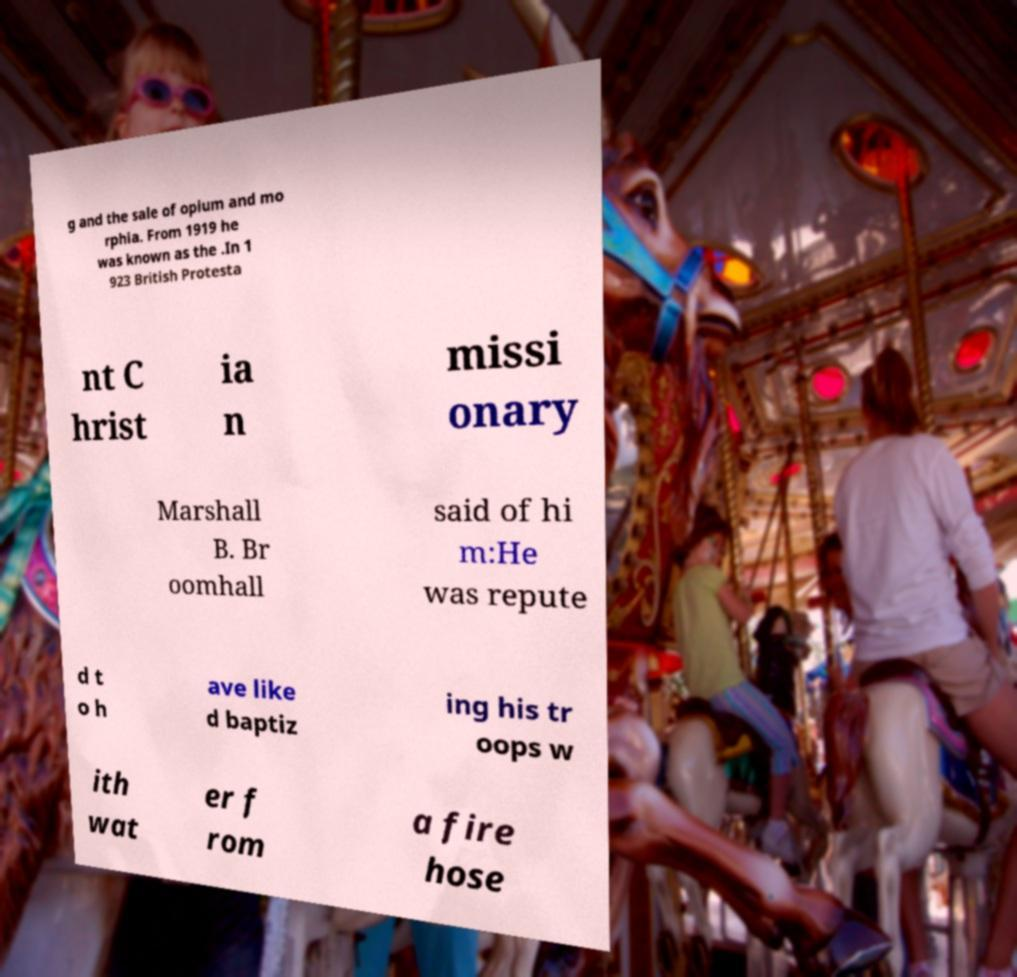Please identify and transcribe the text found in this image. g and the sale of opium and mo rphia. From 1919 he was known as the .In 1 923 British Protesta nt C hrist ia n missi onary Marshall B. Br oomhall said of hi m:He was repute d t o h ave like d baptiz ing his tr oops w ith wat er f rom a fire hose 